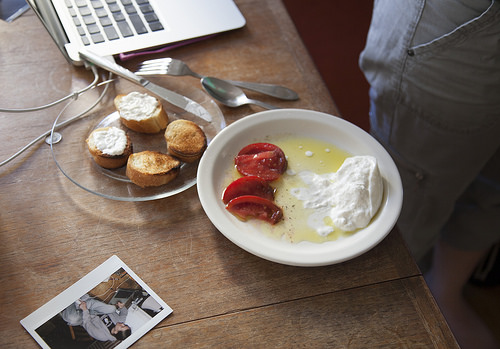<image>
Is there a tomato in the fork? No. The tomato is not contained within the fork. These objects have a different spatial relationship. Is there a knife on the table? Yes. Looking at the image, I can see the knife is positioned on top of the table, with the table providing support. 